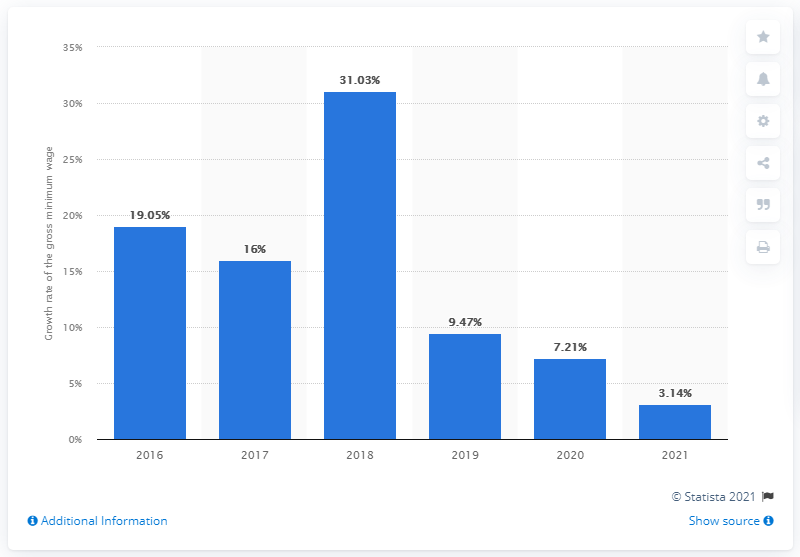Point out several critical features in this image. In 2017, the minimum monthly income increased by 31.03 percent. 